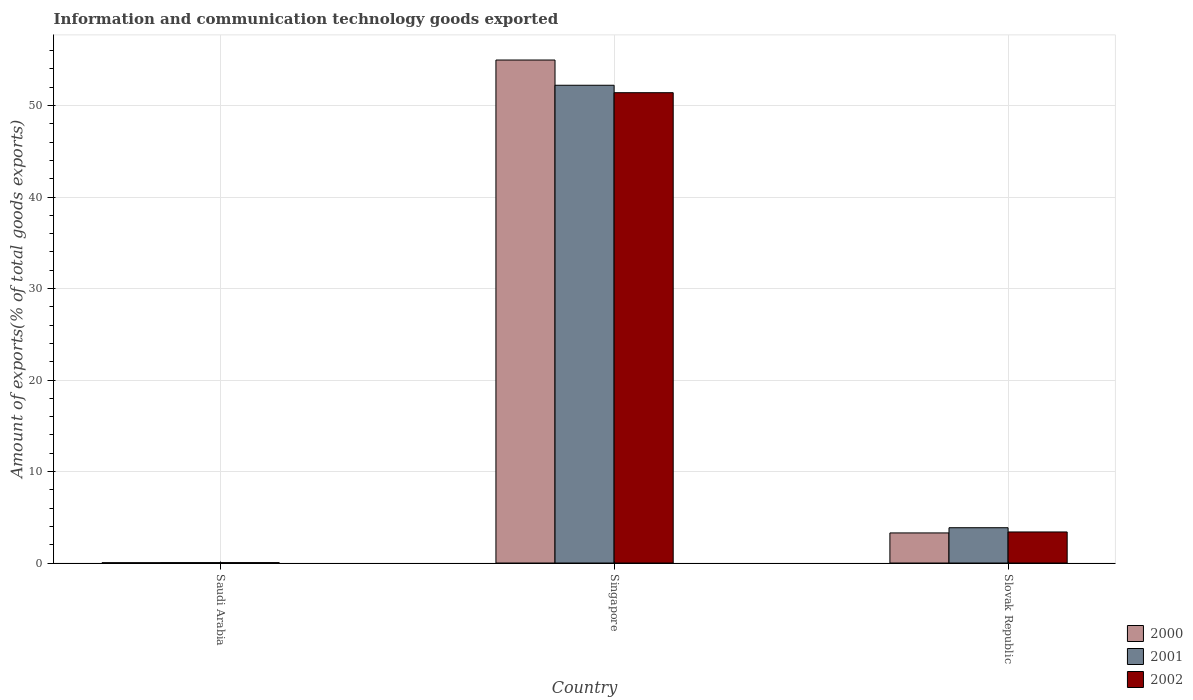How many different coloured bars are there?
Keep it short and to the point. 3. How many groups of bars are there?
Provide a succinct answer. 3. What is the label of the 1st group of bars from the left?
Offer a terse response. Saudi Arabia. In how many cases, is the number of bars for a given country not equal to the number of legend labels?
Offer a very short reply. 0. What is the amount of goods exported in 2001 in Slovak Republic?
Your response must be concise. 3.86. Across all countries, what is the maximum amount of goods exported in 2002?
Provide a succinct answer. 51.4. Across all countries, what is the minimum amount of goods exported in 2001?
Provide a succinct answer. 0.04. In which country was the amount of goods exported in 2000 maximum?
Give a very brief answer. Singapore. In which country was the amount of goods exported in 2002 minimum?
Give a very brief answer. Saudi Arabia. What is the total amount of goods exported in 2001 in the graph?
Make the answer very short. 56.12. What is the difference between the amount of goods exported in 2002 in Saudi Arabia and that in Slovak Republic?
Keep it short and to the point. -3.35. What is the difference between the amount of goods exported in 2001 in Singapore and the amount of goods exported in 2002 in Saudi Arabia?
Provide a succinct answer. 52.17. What is the average amount of goods exported in 2000 per country?
Offer a terse response. 19.43. What is the difference between the amount of goods exported of/in 2000 and amount of goods exported of/in 2001 in Slovak Republic?
Offer a terse response. -0.57. What is the ratio of the amount of goods exported in 2000 in Saudi Arabia to that in Slovak Republic?
Keep it short and to the point. 0.01. Is the amount of goods exported in 2001 in Saudi Arabia less than that in Slovak Republic?
Keep it short and to the point. Yes. What is the difference between the highest and the second highest amount of goods exported in 2001?
Provide a short and direct response. -3.82. What is the difference between the highest and the lowest amount of goods exported in 2001?
Your answer should be very brief. 52.17. In how many countries, is the amount of goods exported in 2001 greater than the average amount of goods exported in 2001 taken over all countries?
Offer a very short reply. 1. What does the 1st bar from the right in Singapore represents?
Your answer should be compact. 2002. Are all the bars in the graph horizontal?
Keep it short and to the point. No. How many countries are there in the graph?
Your answer should be compact. 3. What is the difference between two consecutive major ticks on the Y-axis?
Keep it short and to the point. 10. How many legend labels are there?
Offer a terse response. 3. How are the legend labels stacked?
Give a very brief answer. Vertical. What is the title of the graph?
Offer a terse response. Information and communication technology goods exported. Does "2015" appear as one of the legend labels in the graph?
Offer a very short reply. No. What is the label or title of the X-axis?
Ensure brevity in your answer.  Country. What is the label or title of the Y-axis?
Provide a succinct answer. Amount of exports(% of total goods exports). What is the Amount of exports(% of total goods exports) in 2000 in Saudi Arabia?
Ensure brevity in your answer.  0.03. What is the Amount of exports(% of total goods exports) of 2001 in Saudi Arabia?
Your answer should be compact. 0.04. What is the Amount of exports(% of total goods exports) in 2002 in Saudi Arabia?
Offer a terse response. 0.04. What is the Amount of exports(% of total goods exports) in 2000 in Singapore?
Your answer should be compact. 54.97. What is the Amount of exports(% of total goods exports) in 2001 in Singapore?
Provide a short and direct response. 52.22. What is the Amount of exports(% of total goods exports) of 2002 in Singapore?
Your answer should be compact. 51.4. What is the Amount of exports(% of total goods exports) of 2000 in Slovak Republic?
Your response must be concise. 3.29. What is the Amount of exports(% of total goods exports) in 2001 in Slovak Republic?
Make the answer very short. 3.86. What is the Amount of exports(% of total goods exports) in 2002 in Slovak Republic?
Your answer should be very brief. 3.4. Across all countries, what is the maximum Amount of exports(% of total goods exports) of 2000?
Provide a succinct answer. 54.97. Across all countries, what is the maximum Amount of exports(% of total goods exports) of 2001?
Offer a terse response. 52.22. Across all countries, what is the maximum Amount of exports(% of total goods exports) of 2002?
Provide a succinct answer. 51.4. Across all countries, what is the minimum Amount of exports(% of total goods exports) of 2000?
Make the answer very short. 0.03. Across all countries, what is the minimum Amount of exports(% of total goods exports) of 2001?
Your answer should be compact. 0.04. Across all countries, what is the minimum Amount of exports(% of total goods exports) in 2002?
Your response must be concise. 0.04. What is the total Amount of exports(% of total goods exports) in 2000 in the graph?
Ensure brevity in your answer.  58.3. What is the total Amount of exports(% of total goods exports) of 2001 in the graph?
Keep it short and to the point. 56.12. What is the total Amount of exports(% of total goods exports) of 2002 in the graph?
Provide a short and direct response. 54.84. What is the difference between the Amount of exports(% of total goods exports) of 2000 in Saudi Arabia and that in Singapore?
Provide a short and direct response. -54.94. What is the difference between the Amount of exports(% of total goods exports) of 2001 in Saudi Arabia and that in Singapore?
Provide a succinct answer. -52.17. What is the difference between the Amount of exports(% of total goods exports) in 2002 in Saudi Arabia and that in Singapore?
Your response must be concise. -51.36. What is the difference between the Amount of exports(% of total goods exports) of 2000 in Saudi Arabia and that in Slovak Republic?
Offer a very short reply. -3.26. What is the difference between the Amount of exports(% of total goods exports) in 2001 in Saudi Arabia and that in Slovak Republic?
Offer a very short reply. -3.82. What is the difference between the Amount of exports(% of total goods exports) of 2002 in Saudi Arabia and that in Slovak Republic?
Your answer should be very brief. -3.35. What is the difference between the Amount of exports(% of total goods exports) of 2000 in Singapore and that in Slovak Republic?
Your response must be concise. 51.69. What is the difference between the Amount of exports(% of total goods exports) of 2001 in Singapore and that in Slovak Republic?
Ensure brevity in your answer.  48.36. What is the difference between the Amount of exports(% of total goods exports) in 2002 in Singapore and that in Slovak Republic?
Give a very brief answer. 48.01. What is the difference between the Amount of exports(% of total goods exports) of 2000 in Saudi Arabia and the Amount of exports(% of total goods exports) of 2001 in Singapore?
Keep it short and to the point. -52.18. What is the difference between the Amount of exports(% of total goods exports) in 2000 in Saudi Arabia and the Amount of exports(% of total goods exports) in 2002 in Singapore?
Your response must be concise. -51.37. What is the difference between the Amount of exports(% of total goods exports) of 2001 in Saudi Arabia and the Amount of exports(% of total goods exports) of 2002 in Singapore?
Provide a succinct answer. -51.36. What is the difference between the Amount of exports(% of total goods exports) of 2000 in Saudi Arabia and the Amount of exports(% of total goods exports) of 2001 in Slovak Republic?
Provide a short and direct response. -3.83. What is the difference between the Amount of exports(% of total goods exports) in 2000 in Saudi Arabia and the Amount of exports(% of total goods exports) in 2002 in Slovak Republic?
Provide a succinct answer. -3.36. What is the difference between the Amount of exports(% of total goods exports) in 2001 in Saudi Arabia and the Amount of exports(% of total goods exports) in 2002 in Slovak Republic?
Make the answer very short. -3.35. What is the difference between the Amount of exports(% of total goods exports) of 2000 in Singapore and the Amount of exports(% of total goods exports) of 2001 in Slovak Republic?
Give a very brief answer. 51.12. What is the difference between the Amount of exports(% of total goods exports) in 2000 in Singapore and the Amount of exports(% of total goods exports) in 2002 in Slovak Republic?
Your response must be concise. 51.58. What is the difference between the Amount of exports(% of total goods exports) of 2001 in Singapore and the Amount of exports(% of total goods exports) of 2002 in Slovak Republic?
Ensure brevity in your answer.  48.82. What is the average Amount of exports(% of total goods exports) in 2000 per country?
Offer a very short reply. 19.43. What is the average Amount of exports(% of total goods exports) in 2001 per country?
Keep it short and to the point. 18.71. What is the average Amount of exports(% of total goods exports) in 2002 per country?
Your answer should be compact. 18.28. What is the difference between the Amount of exports(% of total goods exports) of 2000 and Amount of exports(% of total goods exports) of 2001 in Saudi Arabia?
Your response must be concise. -0.01. What is the difference between the Amount of exports(% of total goods exports) in 2000 and Amount of exports(% of total goods exports) in 2002 in Saudi Arabia?
Give a very brief answer. -0.01. What is the difference between the Amount of exports(% of total goods exports) of 2001 and Amount of exports(% of total goods exports) of 2002 in Saudi Arabia?
Provide a short and direct response. -0. What is the difference between the Amount of exports(% of total goods exports) in 2000 and Amount of exports(% of total goods exports) in 2001 in Singapore?
Your answer should be very brief. 2.76. What is the difference between the Amount of exports(% of total goods exports) in 2000 and Amount of exports(% of total goods exports) in 2002 in Singapore?
Offer a very short reply. 3.57. What is the difference between the Amount of exports(% of total goods exports) of 2001 and Amount of exports(% of total goods exports) of 2002 in Singapore?
Provide a succinct answer. 0.81. What is the difference between the Amount of exports(% of total goods exports) in 2000 and Amount of exports(% of total goods exports) in 2001 in Slovak Republic?
Provide a short and direct response. -0.57. What is the difference between the Amount of exports(% of total goods exports) in 2000 and Amount of exports(% of total goods exports) in 2002 in Slovak Republic?
Your response must be concise. -0.11. What is the difference between the Amount of exports(% of total goods exports) of 2001 and Amount of exports(% of total goods exports) of 2002 in Slovak Republic?
Your answer should be very brief. 0.46. What is the ratio of the Amount of exports(% of total goods exports) of 2000 in Saudi Arabia to that in Singapore?
Give a very brief answer. 0. What is the ratio of the Amount of exports(% of total goods exports) of 2001 in Saudi Arabia to that in Singapore?
Ensure brevity in your answer.  0. What is the ratio of the Amount of exports(% of total goods exports) in 2002 in Saudi Arabia to that in Singapore?
Your response must be concise. 0. What is the ratio of the Amount of exports(% of total goods exports) in 2000 in Saudi Arabia to that in Slovak Republic?
Your response must be concise. 0.01. What is the ratio of the Amount of exports(% of total goods exports) in 2001 in Saudi Arabia to that in Slovak Republic?
Keep it short and to the point. 0.01. What is the ratio of the Amount of exports(% of total goods exports) of 2002 in Saudi Arabia to that in Slovak Republic?
Your answer should be compact. 0.01. What is the ratio of the Amount of exports(% of total goods exports) in 2000 in Singapore to that in Slovak Republic?
Your response must be concise. 16.71. What is the ratio of the Amount of exports(% of total goods exports) of 2001 in Singapore to that in Slovak Republic?
Offer a terse response. 13.53. What is the ratio of the Amount of exports(% of total goods exports) of 2002 in Singapore to that in Slovak Republic?
Provide a short and direct response. 15.14. What is the difference between the highest and the second highest Amount of exports(% of total goods exports) in 2000?
Keep it short and to the point. 51.69. What is the difference between the highest and the second highest Amount of exports(% of total goods exports) in 2001?
Give a very brief answer. 48.36. What is the difference between the highest and the second highest Amount of exports(% of total goods exports) in 2002?
Ensure brevity in your answer.  48.01. What is the difference between the highest and the lowest Amount of exports(% of total goods exports) of 2000?
Ensure brevity in your answer.  54.94. What is the difference between the highest and the lowest Amount of exports(% of total goods exports) in 2001?
Make the answer very short. 52.17. What is the difference between the highest and the lowest Amount of exports(% of total goods exports) in 2002?
Give a very brief answer. 51.36. 